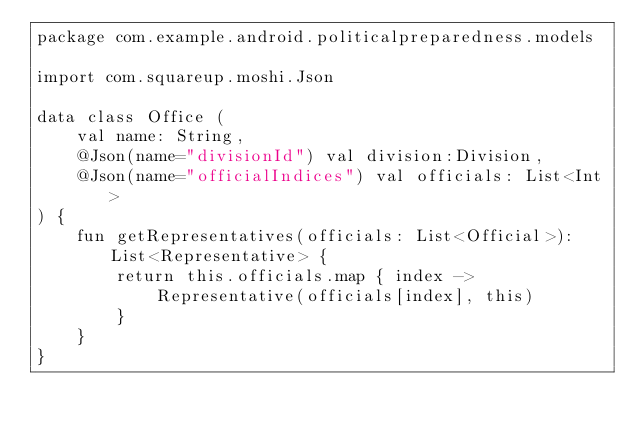<code> <loc_0><loc_0><loc_500><loc_500><_Kotlin_>package com.example.android.politicalpreparedness.models

import com.squareup.moshi.Json

data class Office (
    val name: String,
    @Json(name="divisionId") val division:Division,
    @Json(name="officialIndices") val officials: List<Int>
) {
    fun getRepresentatives(officials: List<Official>): List<Representative> {
        return this.officials.map { index ->
            Representative(officials[index], this)
        }
    }
}
</code> 